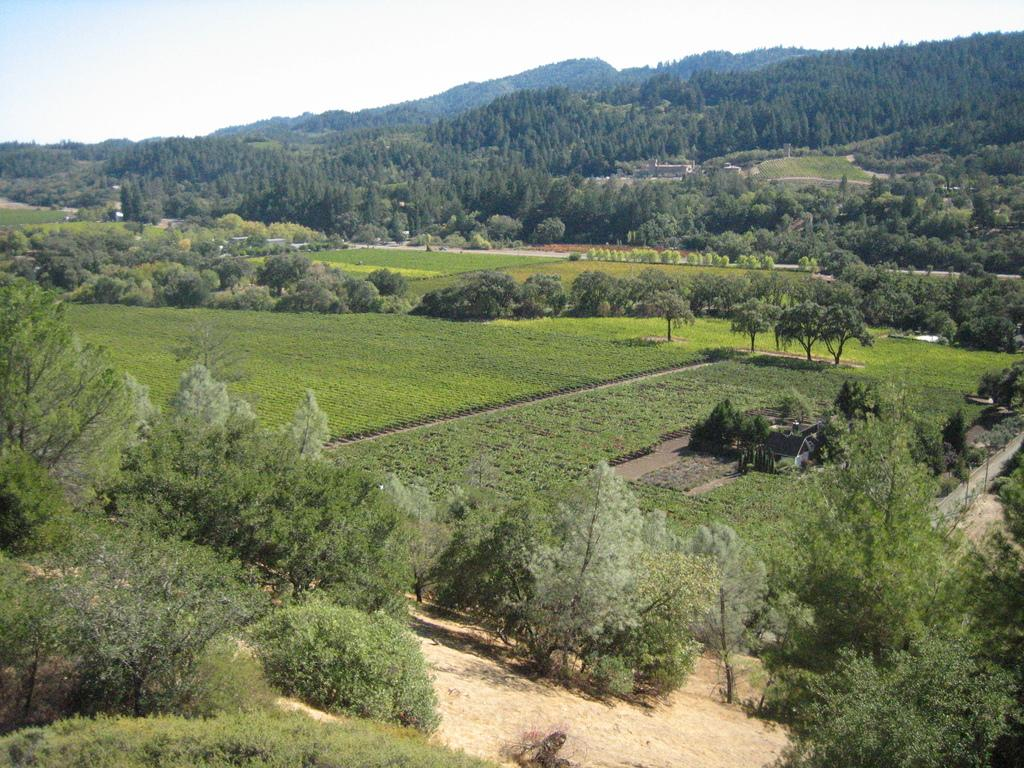What type of vegetation can be seen in the image? There are trees in the image. What is the ground covered with in the image? The ground is covered in greenery. What type of judge is present in the image? There is no judge present in the image; it only features trees and greenery. What station is visible in the image? There is no station present in the image; it only features trees and greeneryenery. 